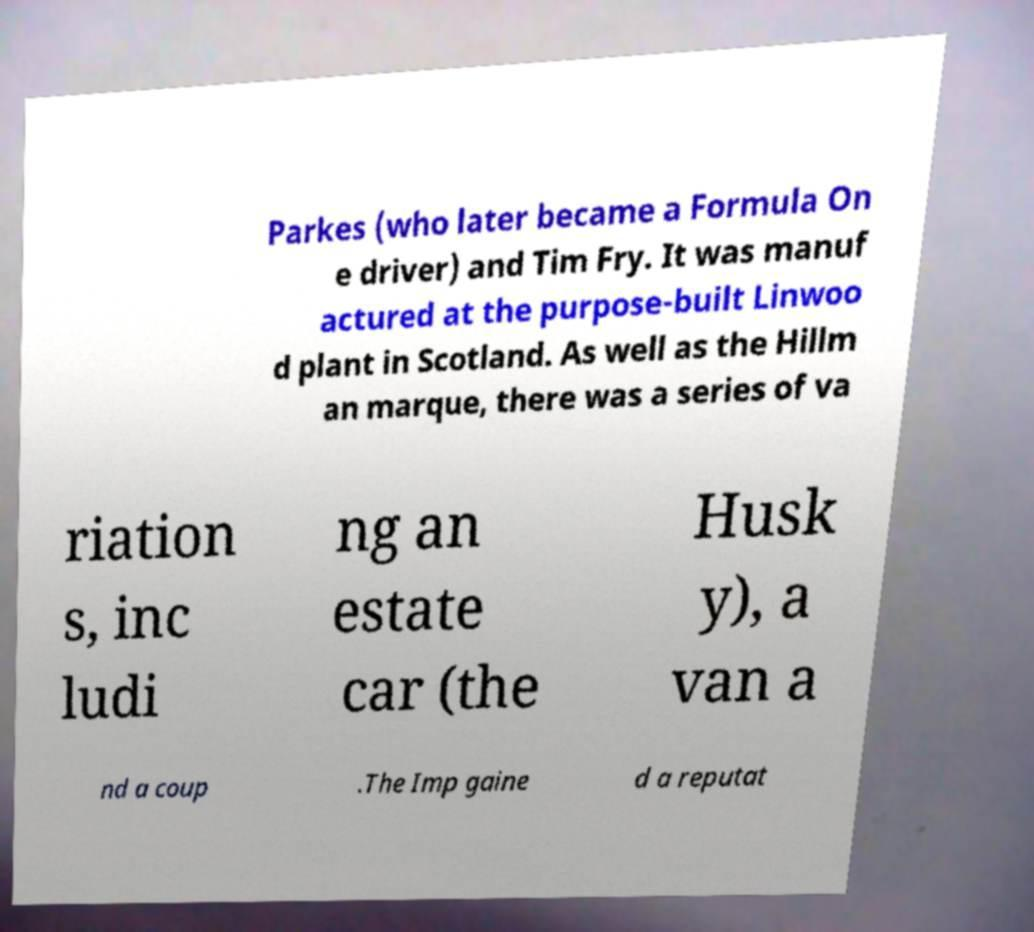Can you accurately transcribe the text from the provided image for me? Parkes (who later became a Formula On e driver) and Tim Fry. It was manuf actured at the purpose-built Linwoo d plant in Scotland. As well as the Hillm an marque, there was a series of va riation s, inc ludi ng an estate car (the Husk y), a van a nd a coup .The Imp gaine d a reputat 